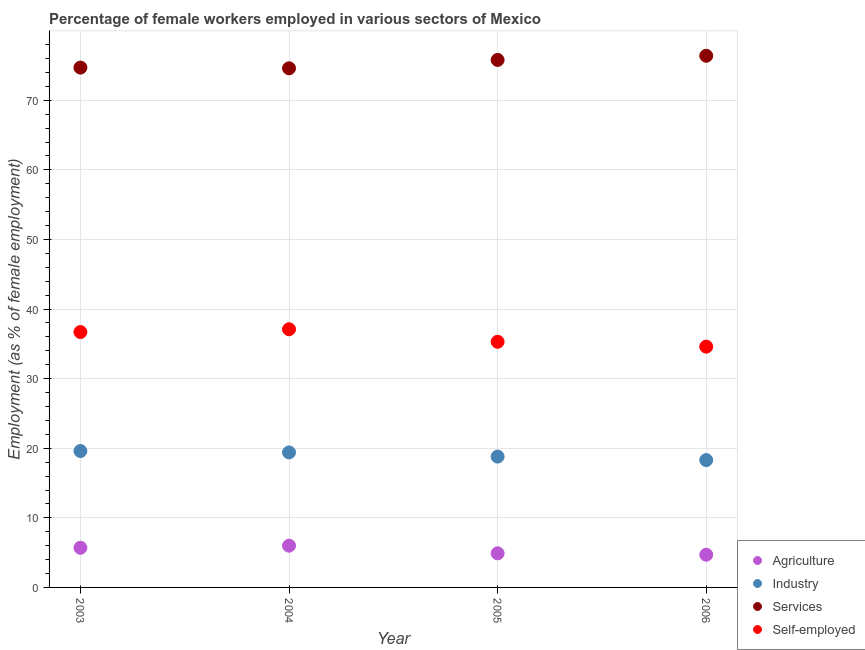How many different coloured dotlines are there?
Offer a terse response. 4. Is the number of dotlines equal to the number of legend labels?
Your response must be concise. Yes. What is the percentage of self employed female workers in 2004?
Ensure brevity in your answer.  37.1. Across all years, what is the maximum percentage of self employed female workers?
Offer a terse response. 37.1. Across all years, what is the minimum percentage of female workers in industry?
Keep it short and to the point. 18.3. In which year was the percentage of female workers in services maximum?
Offer a very short reply. 2006. In which year was the percentage of female workers in services minimum?
Offer a very short reply. 2004. What is the total percentage of self employed female workers in the graph?
Provide a succinct answer. 143.7. What is the difference between the percentage of female workers in agriculture in 2003 and that in 2004?
Your answer should be compact. -0.3. What is the difference between the percentage of female workers in agriculture in 2005 and the percentage of self employed female workers in 2004?
Ensure brevity in your answer.  -32.2. What is the average percentage of female workers in industry per year?
Offer a very short reply. 19.02. In the year 2003, what is the difference between the percentage of female workers in industry and percentage of self employed female workers?
Give a very brief answer. -17.1. In how many years, is the percentage of self employed female workers greater than 40 %?
Give a very brief answer. 0. What is the ratio of the percentage of female workers in services in 2003 to that in 2005?
Provide a short and direct response. 0.99. Is the percentage of female workers in industry in 2003 less than that in 2006?
Give a very brief answer. No. Is the difference between the percentage of female workers in services in 2004 and 2005 greater than the difference between the percentage of self employed female workers in 2004 and 2005?
Your answer should be very brief. No. What is the difference between the highest and the second highest percentage of female workers in agriculture?
Give a very brief answer. 0.3. What is the difference between the highest and the lowest percentage of female workers in industry?
Give a very brief answer. 1.3. Is the percentage of self employed female workers strictly greater than the percentage of female workers in agriculture over the years?
Offer a very short reply. Yes. Is the percentage of female workers in services strictly less than the percentage of female workers in industry over the years?
Offer a very short reply. No. How many years are there in the graph?
Your response must be concise. 4. Does the graph contain grids?
Your answer should be very brief. Yes. How many legend labels are there?
Offer a terse response. 4. How are the legend labels stacked?
Your answer should be very brief. Vertical. What is the title of the graph?
Provide a short and direct response. Percentage of female workers employed in various sectors of Mexico. Does "Energy" appear as one of the legend labels in the graph?
Ensure brevity in your answer.  No. What is the label or title of the X-axis?
Offer a very short reply. Year. What is the label or title of the Y-axis?
Provide a succinct answer. Employment (as % of female employment). What is the Employment (as % of female employment) in Agriculture in 2003?
Keep it short and to the point. 5.7. What is the Employment (as % of female employment) of Industry in 2003?
Your answer should be very brief. 19.6. What is the Employment (as % of female employment) in Services in 2003?
Your answer should be very brief. 74.7. What is the Employment (as % of female employment) of Self-employed in 2003?
Give a very brief answer. 36.7. What is the Employment (as % of female employment) of Agriculture in 2004?
Provide a succinct answer. 6. What is the Employment (as % of female employment) of Industry in 2004?
Keep it short and to the point. 19.4. What is the Employment (as % of female employment) of Services in 2004?
Offer a very short reply. 74.6. What is the Employment (as % of female employment) in Self-employed in 2004?
Provide a succinct answer. 37.1. What is the Employment (as % of female employment) in Agriculture in 2005?
Provide a succinct answer. 4.9. What is the Employment (as % of female employment) of Industry in 2005?
Make the answer very short. 18.8. What is the Employment (as % of female employment) in Services in 2005?
Your response must be concise. 75.8. What is the Employment (as % of female employment) of Self-employed in 2005?
Provide a succinct answer. 35.3. What is the Employment (as % of female employment) of Agriculture in 2006?
Give a very brief answer. 4.7. What is the Employment (as % of female employment) of Industry in 2006?
Keep it short and to the point. 18.3. What is the Employment (as % of female employment) in Services in 2006?
Your answer should be compact. 76.4. What is the Employment (as % of female employment) in Self-employed in 2006?
Offer a very short reply. 34.6. Across all years, what is the maximum Employment (as % of female employment) of Industry?
Offer a very short reply. 19.6. Across all years, what is the maximum Employment (as % of female employment) in Services?
Offer a very short reply. 76.4. Across all years, what is the maximum Employment (as % of female employment) of Self-employed?
Offer a very short reply. 37.1. Across all years, what is the minimum Employment (as % of female employment) of Agriculture?
Your response must be concise. 4.7. Across all years, what is the minimum Employment (as % of female employment) of Industry?
Your response must be concise. 18.3. Across all years, what is the minimum Employment (as % of female employment) in Services?
Keep it short and to the point. 74.6. Across all years, what is the minimum Employment (as % of female employment) in Self-employed?
Your answer should be very brief. 34.6. What is the total Employment (as % of female employment) in Agriculture in the graph?
Your answer should be very brief. 21.3. What is the total Employment (as % of female employment) in Industry in the graph?
Keep it short and to the point. 76.1. What is the total Employment (as % of female employment) of Services in the graph?
Offer a very short reply. 301.5. What is the total Employment (as % of female employment) of Self-employed in the graph?
Ensure brevity in your answer.  143.7. What is the difference between the Employment (as % of female employment) in Agriculture in 2003 and that in 2004?
Offer a very short reply. -0.3. What is the difference between the Employment (as % of female employment) of Services in 2003 and that in 2004?
Provide a succinct answer. 0.1. What is the difference between the Employment (as % of female employment) of Self-employed in 2003 and that in 2004?
Provide a succinct answer. -0.4. What is the difference between the Employment (as % of female employment) in Industry in 2003 and that in 2005?
Your response must be concise. 0.8. What is the difference between the Employment (as % of female employment) of Self-employed in 2003 and that in 2005?
Provide a succinct answer. 1.4. What is the difference between the Employment (as % of female employment) in Agriculture in 2003 and that in 2006?
Give a very brief answer. 1. What is the difference between the Employment (as % of female employment) in Agriculture in 2004 and that in 2005?
Make the answer very short. 1.1. What is the difference between the Employment (as % of female employment) in Services in 2004 and that in 2005?
Your answer should be compact. -1.2. What is the difference between the Employment (as % of female employment) in Industry in 2004 and that in 2006?
Offer a terse response. 1.1. What is the difference between the Employment (as % of female employment) of Agriculture in 2005 and that in 2006?
Keep it short and to the point. 0.2. What is the difference between the Employment (as % of female employment) in Services in 2005 and that in 2006?
Give a very brief answer. -0.6. What is the difference between the Employment (as % of female employment) in Agriculture in 2003 and the Employment (as % of female employment) in Industry in 2004?
Ensure brevity in your answer.  -13.7. What is the difference between the Employment (as % of female employment) of Agriculture in 2003 and the Employment (as % of female employment) of Services in 2004?
Give a very brief answer. -68.9. What is the difference between the Employment (as % of female employment) of Agriculture in 2003 and the Employment (as % of female employment) of Self-employed in 2004?
Your answer should be compact. -31.4. What is the difference between the Employment (as % of female employment) of Industry in 2003 and the Employment (as % of female employment) of Services in 2004?
Give a very brief answer. -55. What is the difference between the Employment (as % of female employment) of Industry in 2003 and the Employment (as % of female employment) of Self-employed in 2004?
Your answer should be very brief. -17.5. What is the difference between the Employment (as % of female employment) in Services in 2003 and the Employment (as % of female employment) in Self-employed in 2004?
Offer a very short reply. 37.6. What is the difference between the Employment (as % of female employment) in Agriculture in 2003 and the Employment (as % of female employment) in Industry in 2005?
Make the answer very short. -13.1. What is the difference between the Employment (as % of female employment) of Agriculture in 2003 and the Employment (as % of female employment) of Services in 2005?
Provide a succinct answer. -70.1. What is the difference between the Employment (as % of female employment) of Agriculture in 2003 and the Employment (as % of female employment) of Self-employed in 2005?
Your response must be concise. -29.6. What is the difference between the Employment (as % of female employment) in Industry in 2003 and the Employment (as % of female employment) in Services in 2005?
Your answer should be compact. -56.2. What is the difference between the Employment (as % of female employment) in Industry in 2003 and the Employment (as % of female employment) in Self-employed in 2005?
Your response must be concise. -15.7. What is the difference between the Employment (as % of female employment) in Services in 2003 and the Employment (as % of female employment) in Self-employed in 2005?
Provide a short and direct response. 39.4. What is the difference between the Employment (as % of female employment) of Agriculture in 2003 and the Employment (as % of female employment) of Services in 2006?
Give a very brief answer. -70.7. What is the difference between the Employment (as % of female employment) in Agriculture in 2003 and the Employment (as % of female employment) in Self-employed in 2006?
Offer a terse response. -28.9. What is the difference between the Employment (as % of female employment) of Industry in 2003 and the Employment (as % of female employment) of Services in 2006?
Ensure brevity in your answer.  -56.8. What is the difference between the Employment (as % of female employment) of Services in 2003 and the Employment (as % of female employment) of Self-employed in 2006?
Keep it short and to the point. 40.1. What is the difference between the Employment (as % of female employment) in Agriculture in 2004 and the Employment (as % of female employment) in Services in 2005?
Give a very brief answer. -69.8. What is the difference between the Employment (as % of female employment) in Agriculture in 2004 and the Employment (as % of female employment) in Self-employed in 2005?
Your response must be concise. -29.3. What is the difference between the Employment (as % of female employment) in Industry in 2004 and the Employment (as % of female employment) in Services in 2005?
Give a very brief answer. -56.4. What is the difference between the Employment (as % of female employment) in Industry in 2004 and the Employment (as % of female employment) in Self-employed in 2005?
Your answer should be very brief. -15.9. What is the difference between the Employment (as % of female employment) in Services in 2004 and the Employment (as % of female employment) in Self-employed in 2005?
Provide a short and direct response. 39.3. What is the difference between the Employment (as % of female employment) of Agriculture in 2004 and the Employment (as % of female employment) of Services in 2006?
Give a very brief answer. -70.4. What is the difference between the Employment (as % of female employment) in Agriculture in 2004 and the Employment (as % of female employment) in Self-employed in 2006?
Ensure brevity in your answer.  -28.6. What is the difference between the Employment (as % of female employment) in Industry in 2004 and the Employment (as % of female employment) in Services in 2006?
Provide a short and direct response. -57. What is the difference between the Employment (as % of female employment) of Industry in 2004 and the Employment (as % of female employment) of Self-employed in 2006?
Provide a short and direct response. -15.2. What is the difference between the Employment (as % of female employment) in Agriculture in 2005 and the Employment (as % of female employment) in Services in 2006?
Provide a short and direct response. -71.5. What is the difference between the Employment (as % of female employment) in Agriculture in 2005 and the Employment (as % of female employment) in Self-employed in 2006?
Ensure brevity in your answer.  -29.7. What is the difference between the Employment (as % of female employment) of Industry in 2005 and the Employment (as % of female employment) of Services in 2006?
Ensure brevity in your answer.  -57.6. What is the difference between the Employment (as % of female employment) of Industry in 2005 and the Employment (as % of female employment) of Self-employed in 2006?
Offer a very short reply. -15.8. What is the difference between the Employment (as % of female employment) of Services in 2005 and the Employment (as % of female employment) of Self-employed in 2006?
Your answer should be compact. 41.2. What is the average Employment (as % of female employment) of Agriculture per year?
Your answer should be compact. 5.33. What is the average Employment (as % of female employment) in Industry per year?
Your response must be concise. 19.02. What is the average Employment (as % of female employment) in Services per year?
Keep it short and to the point. 75.38. What is the average Employment (as % of female employment) of Self-employed per year?
Keep it short and to the point. 35.92. In the year 2003, what is the difference between the Employment (as % of female employment) in Agriculture and Employment (as % of female employment) in Services?
Keep it short and to the point. -69. In the year 2003, what is the difference between the Employment (as % of female employment) of Agriculture and Employment (as % of female employment) of Self-employed?
Your answer should be very brief. -31. In the year 2003, what is the difference between the Employment (as % of female employment) in Industry and Employment (as % of female employment) in Services?
Make the answer very short. -55.1. In the year 2003, what is the difference between the Employment (as % of female employment) in Industry and Employment (as % of female employment) in Self-employed?
Make the answer very short. -17.1. In the year 2004, what is the difference between the Employment (as % of female employment) of Agriculture and Employment (as % of female employment) of Services?
Keep it short and to the point. -68.6. In the year 2004, what is the difference between the Employment (as % of female employment) in Agriculture and Employment (as % of female employment) in Self-employed?
Offer a very short reply. -31.1. In the year 2004, what is the difference between the Employment (as % of female employment) of Industry and Employment (as % of female employment) of Services?
Provide a short and direct response. -55.2. In the year 2004, what is the difference between the Employment (as % of female employment) in Industry and Employment (as % of female employment) in Self-employed?
Your answer should be compact. -17.7. In the year 2004, what is the difference between the Employment (as % of female employment) in Services and Employment (as % of female employment) in Self-employed?
Keep it short and to the point. 37.5. In the year 2005, what is the difference between the Employment (as % of female employment) of Agriculture and Employment (as % of female employment) of Industry?
Your answer should be compact. -13.9. In the year 2005, what is the difference between the Employment (as % of female employment) of Agriculture and Employment (as % of female employment) of Services?
Provide a succinct answer. -70.9. In the year 2005, what is the difference between the Employment (as % of female employment) of Agriculture and Employment (as % of female employment) of Self-employed?
Give a very brief answer. -30.4. In the year 2005, what is the difference between the Employment (as % of female employment) in Industry and Employment (as % of female employment) in Services?
Give a very brief answer. -57. In the year 2005, what is the difference between the Employment (as % of female employment) in Industry and Employment (as % of female employment) in Self-employed?
Give a very brief answer. -16.5. In the year 2005, what is the difference between the Employment (as % of female employment) in Services and Employment (as % of female employment) in Self-employed?
Your response must be concise. 40.5. In the year 2006, what is the difference between the Employment (as % of female employment) of Agriculture and Employment (as % of female employment) of Industry?
Keep it short and to the point. -13.6. In the year 2006, what is the difference between the Employment (as % of female employment) in Agriculture and Employment (as % of female employment) in Services?
Provide a short and direct response. -71.7. In the year 2006, what is the difference between the Employment (as % of female employment) in Agriculture and Employment (as % of female employment) in Self-employed?
Offer a very short reply. -29.9. In the year 2006, what is the difference between the Employment (as % of female employment) in Industry and Employment (as % of female employment) in Services?
Give a very brief answer. -58.1. In the year 2006, what is the difference between the Employment (as % of female employment) in Industry and Employment (as % of female employment) in Self-employed?
Make the answer very short. -16.3. In the year 2006, what is the difference between the Employment (as % of female employment) of Services and Employment (as % of female employment) of Self-employed?
Give a very brief answer. 41.8. What is the ratio of the Employment (as % of female employment) in Agriculture in 2003 to that in 2004?
Your answer should be very brief. 0.95. What is the ratio of the Employment (as % of female employment) in Industry in 2003 to that in 2004?
Give a very brief answer. 1.01. What is the ratio of the Employment (as % of female employment) of Agriculture in 2003 to that in 2005?
Provide a short and direct response. 1.16. What is the ratio of the Employment (as % of female employment) of Industry in 2003 to that in 2005?
Keep it short and to the point. 1.04. What is the ratio of the Employment (as % of female employment) in Services in 2003 to that in 2005?
Your answer should be very brief. 0.99. What is the ratio of the Employment (as % of female employment) in Self-employed in 2003 to that in 2005?
Make the answer very short. 1.04. What is the ratio of the Employment (as % of female employment) of Agriculture in 2003 to that in 2006?
Your response must be concise. 1.21. What is the ratio of the Employment (as % of female employment) of Industry in 2003 to that in 2006?
Your response must be concise. 1.07. What is the ratio of the Employment (as % of female employment) of Services in 2003 to that in 2006?
Make the answer very short. 0.98. What is the ratio of the Employment (as % of female employment) in Self-employed in 2003 to that in 2006?
Offer a terse response. 1.06. What is the ratio of the Employment (as % of female employment) in Agriculture in 2004 to that in 2005?
Offer a very short reply. 1.22. What is the ratio of the Employment (as % of female employment) in Industry in 2004 to that in 2005?
Provide a short and direct response. 1.03. What is the ratio of the Employment (as % of female employment) in Services in 2004 to that in 2005?
Keep it short and to the point. 0.98. What is the ratio of the Employment (as % of female employment) of Self-employed in 2004 to that in 2005?
Give a very brief answer. 1.05. What is the ratio of the Employment (as % of female employment) in Agriculture in 2004 to that in 2006?
Provide a short and direct response. 1.28. What is the ratio of the Employment (as % of female employment) of Industry in 2004 to that in 2006?
Ensure brevity in your answer.  1.06. What is the ratio of the Employment (as % of female employment) of Services in 2004 to that in 2006?
Provide a succinct answer. 0.98. What is the ratio of the Employment (as % of female employment) in Self-employed in 2004 to that in 2006?
Your answer should be compact. 1.07. What is the ratio of the Employment (as % of female employment) in Agriculture in 2005 to that in 2006?
Offer a very short reply. 1.04. What is the ratio of the Employment (as % of female employment) of Industry in 2005 to that in 2006?
Ensure brevity in your answer.  1.03. What is the ratio of the Employment (as % of female employment) of Self-employed in 2005 to that in 2006?
Keep it short and to the point. 1.02. What is the difference between the highest and the second highest Employment (as % of female employment) in Services?
Your answer should be very brief. 0.6. What is the difference between the highest and the lowest Employment (as % of female employment) of Industry?
Keep it short and to the point. 1.3. What is the difference between the highest and the lowest Employment (as % of female employment) in Services?
Offer a terse response. 1.8. What is the difference between the highest and the lowest Employment (as % of female employment) in Self-employed?
Your response must be concise. 2.5. 